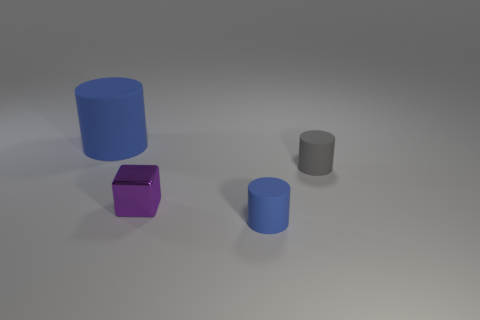Add 1 purple blocks. How many objects exist? 5 Subtract all cylinders. How many objects are left? 1 Subtract all small green cubes. Subtract all big rubber things. How many objects are left? 3 Add 2 rubber cylinders. How many rubber cylinders are left? 5 Add 2 big yellow metal objects. How many big yellow metal objects exist? 2 Subtract 0 red balls. How many objects are left? 4 